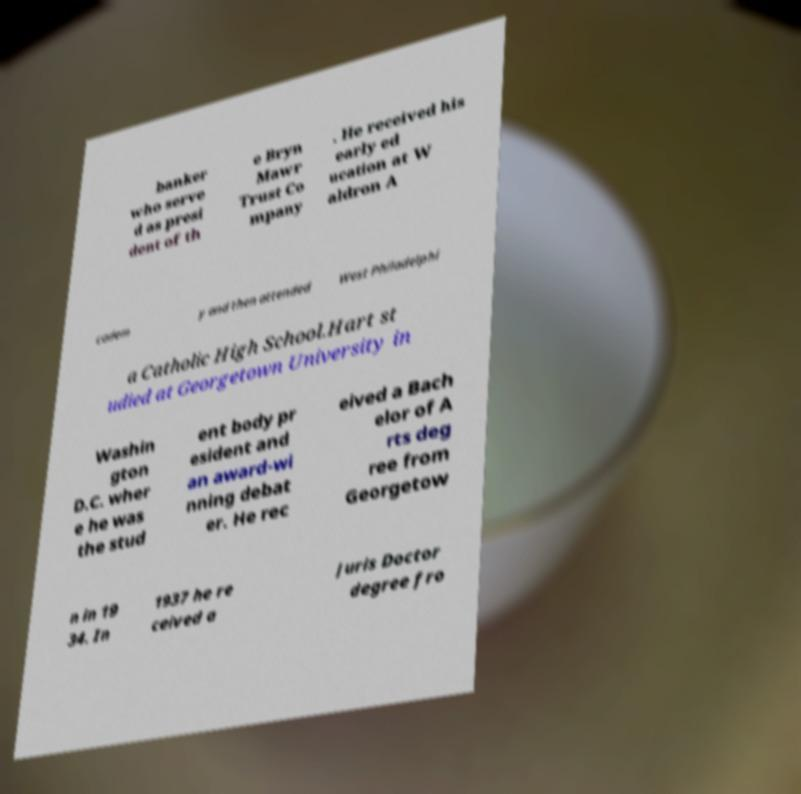Please identify and transcribe the text found in this image. banker who serve d as presi dent of th e Bryn Mawr Trust Co mpany . He received his early ed ucation at W aldron A cadem y and then attended West Philadelphi a Catholic High School.Hart st udied at Georgetown University in Washin gton D.C. wher e he was the stud ent body pr esident and an award-wi nning debat er. He rec eived a Bach elor of A rts deg ree from Georgetow n in 19 34. In 1937 he re ceived a Juris Doctor degree fro 